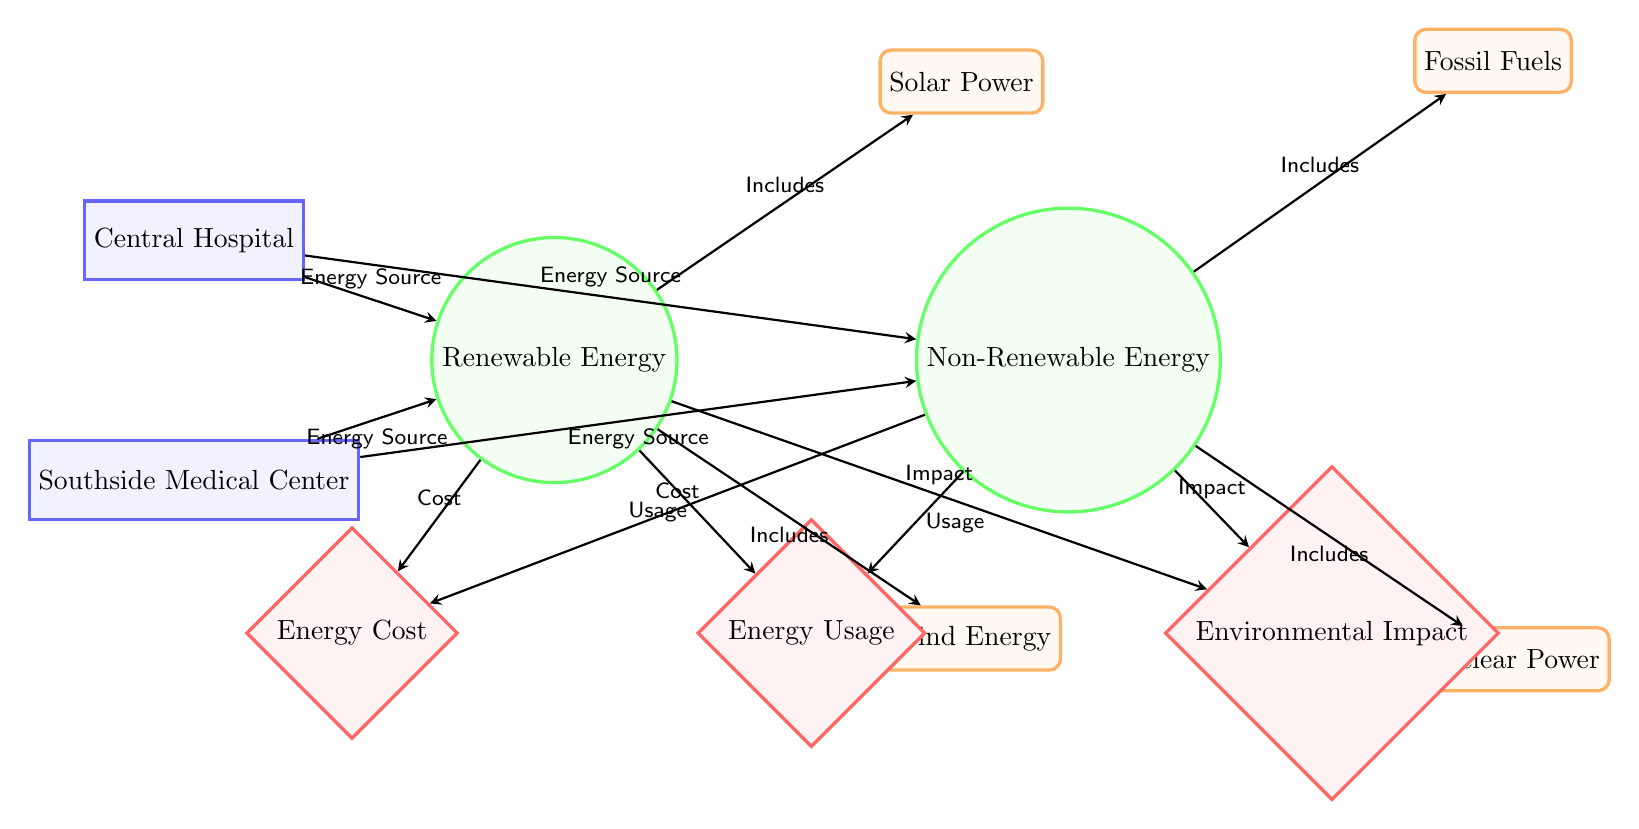What are the two types of energy shown in the diagram? The diagram explicitly labels two types of energy: Renewable Energy and Non-Renewable Energy. These are represented as circular nodes in the diagram adjacent to the hospitals.
Answer: Renewable Energy and Non-Renewable Energy Which hospital is connected to Solar Power? The arrow indicates that the connection from Central Hospital to Renewable Energy includes Solar Power, which is an energy source under Renewable Energy. Thus, Central Hospital is connected to Solar Power.
Answer: Central Hospital How many sources of Non-Renewable Energy are represented? The diagram shows two sources of Non-Renewable Energy: Fossil Fuels and Nuclear Power. Each source is represented within the Non-Renewable Energy category, which indicates that there are two sources.
Answer: Two Which hospital uses both types of energy? Each hospital is represented with an arrow connecting to both types of energy, indicating both are used. Therefore, both Central Hospital and Southside Medical Center are using both types.
Answer: Both hospitals What is the connection labeled as "Usage"? The metric labeled "Energy Usage" appears below both energy types, indicating that the usage of both Renewable and Non-Renewable energy is being measured and connected through the labeled arrow.
Answer: Energy Usage 